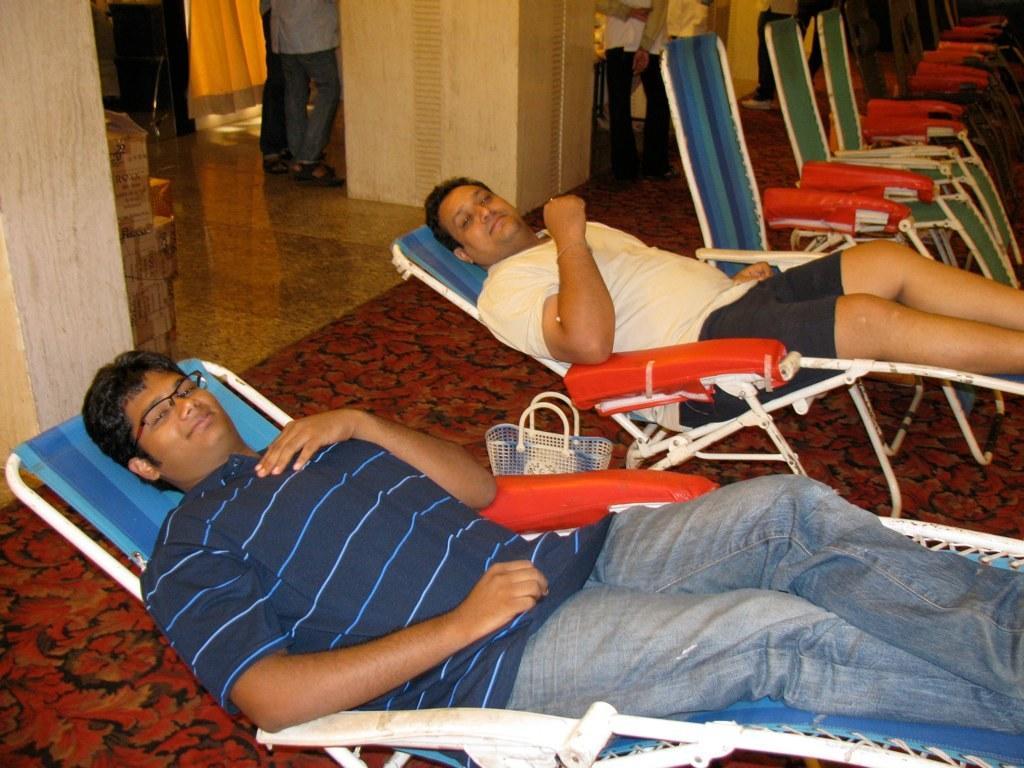Describe this image in one or two sentences. In the foreground of this picture, there are two men lying on the chairs and a basket on the floor. In the background, there are many cars, a pillar, floor, few persons standing, curtain and few card board boxes. 